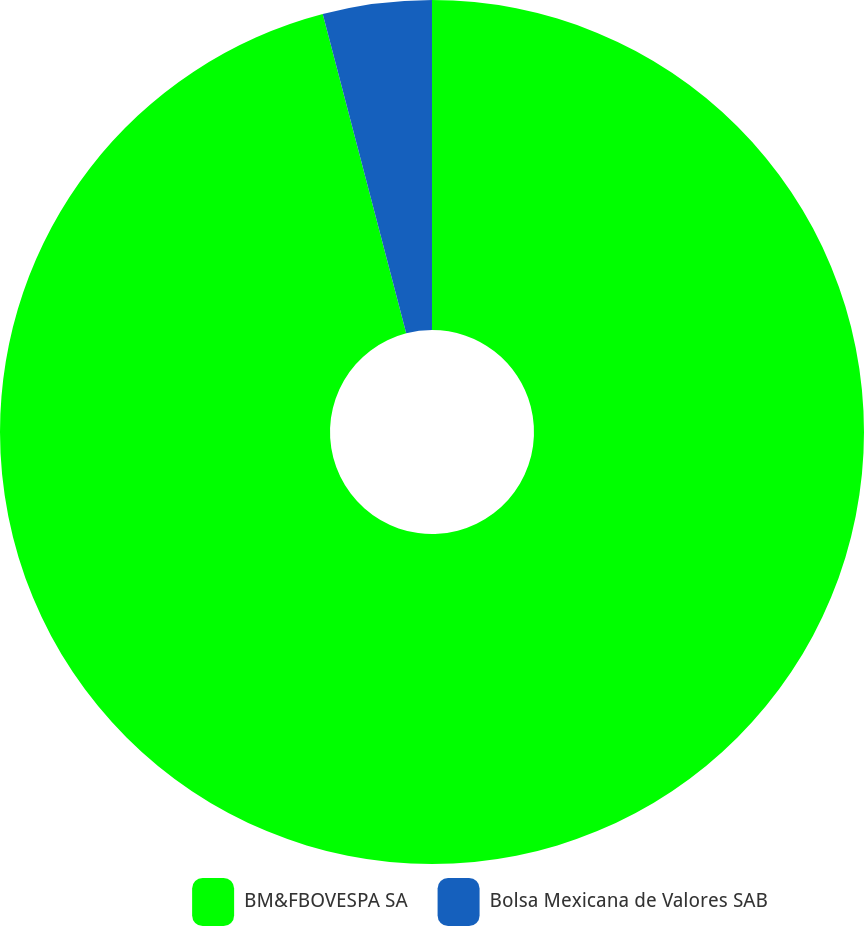Convert chart to OTSL. <chart><loc_0><loc_0><loc_500><loc_500><pie_chart><fcel>BM&FBOVESPA SA<fcel>Bolsa Mexicana de Valores SAB<nl><fcel>95.93%<fcel>4.07%<nl></chart> 